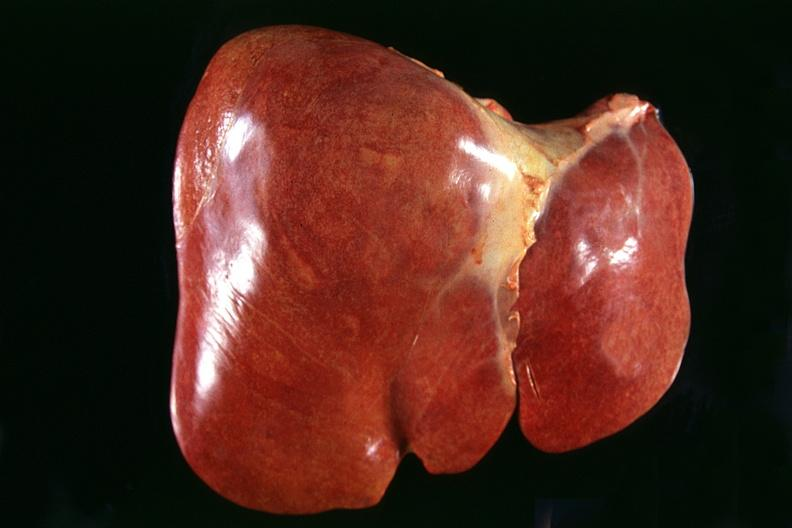s hepatobiliary present?
Answer the question using a single word or phrase. Yes 